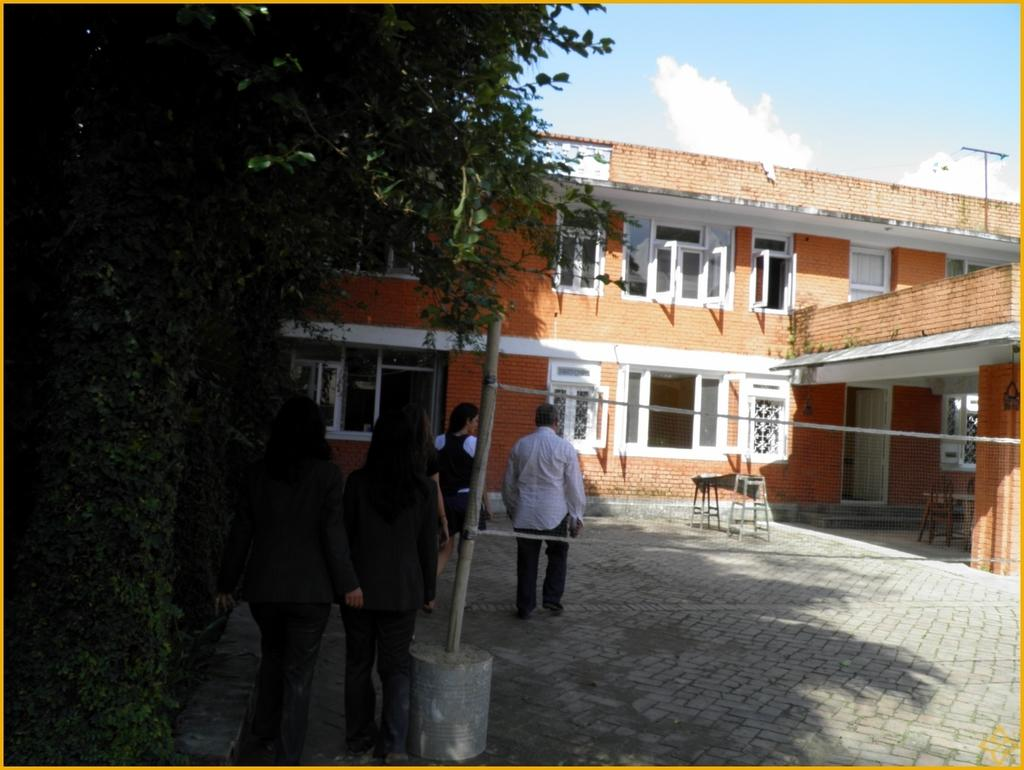How many people are present in the image? There are four persons in the image. What type of natural elements can be seen in the image? There are trees in the image. What type of structure is visible in the image? There is a building in the image. What architectural features are present in the image? There are doors and windows in the image. What type of furniture is visible in the image? There is a table in the image. What can be seen in the background of the image? The sky is visible in the background of the image. What substance is leaking from the trees in the image? There is no substance leaking from the trees in the image; the trees are not depicted as having any issues or abnormalities. What causes the trees to burst in the image? There is no indication of any trees bursting in the image; the trees are depicted as normal, healthy trees. 